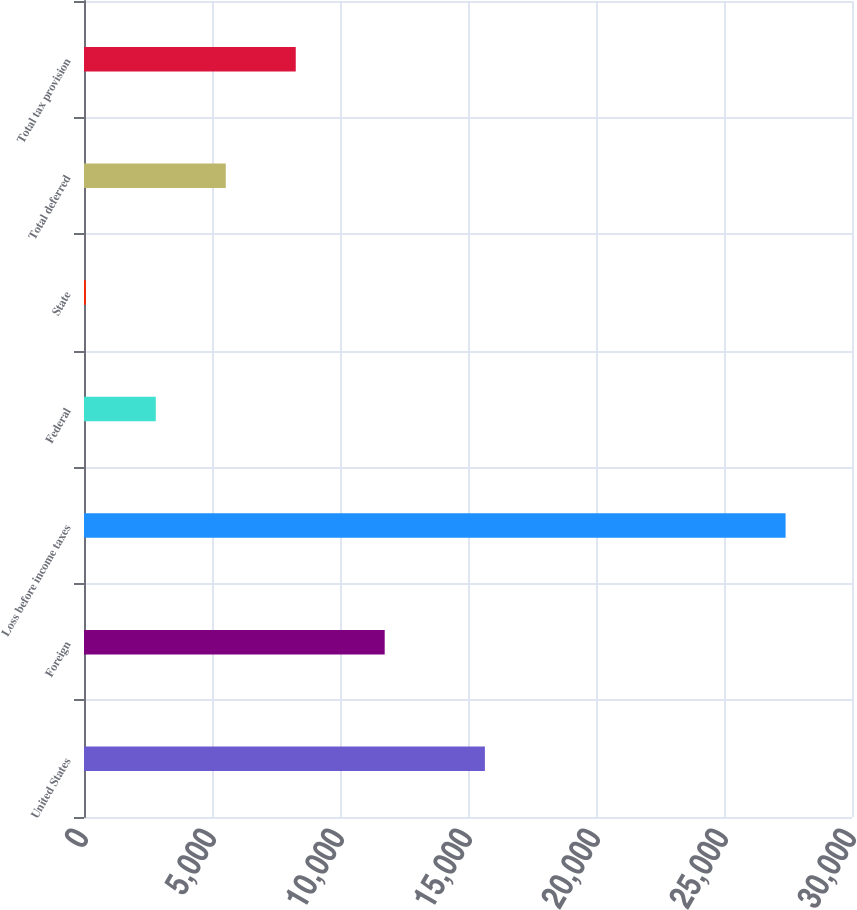<chart> <loc_0><loc_0><loc_500><loc_500><bar_chart><fcel>United States<fcel>Foreign<fcel>Loss before income taxes<fcel>Federal<fcel>State<fcel>Total deferred<fcel>Total tax provision<nl><fcel>15660<fcel>11746<fcel>27406<fcel>2804.5<fcel>71<fcel>5538<fcel>8271.5<nl></chart> 